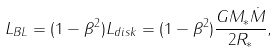<formula> <loc_0><loc_0><loc_500><loc_500>L _ { B L } = ( 1 - \beta ^ { 2 } ) L _ { d i s k } = ( 1 - \beta ^ { 2 } ) \frac { G M _ { * } \dot { M } } { 2 R _ { * } } ,</formula> 